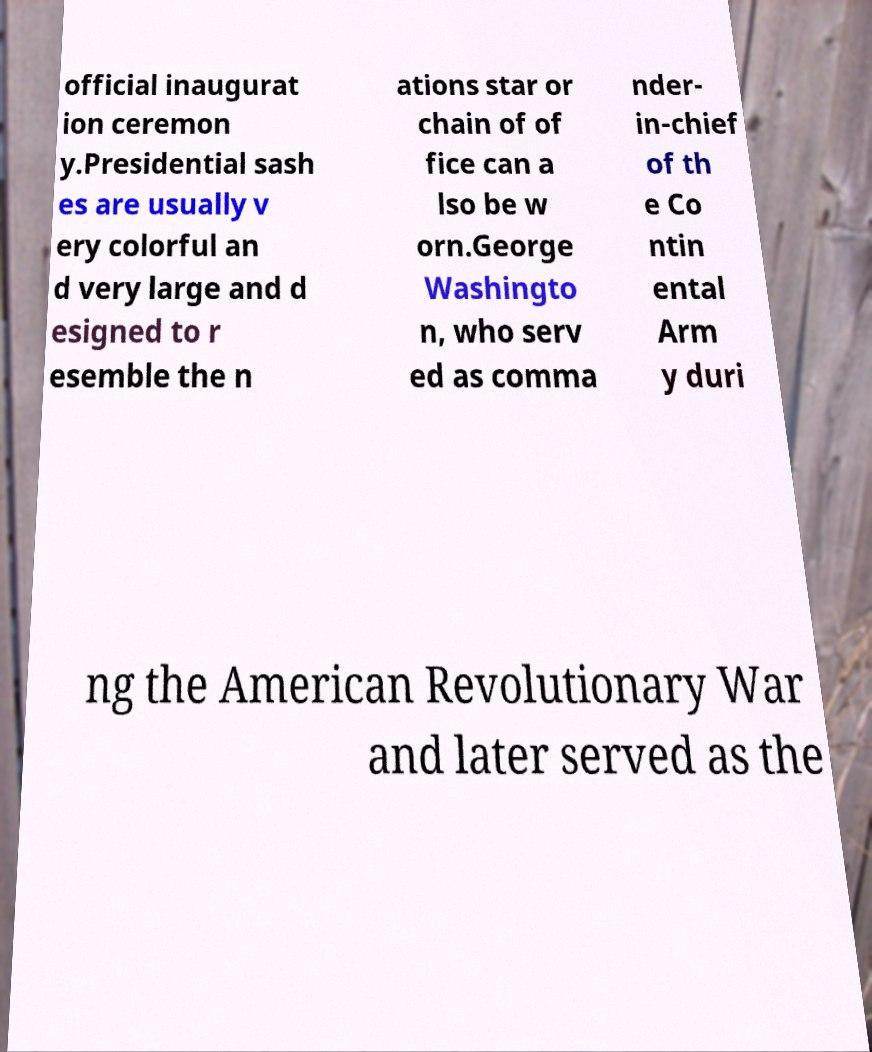There's text embedded in this image that I need extracted. Can you transcribe it verbatim? official inaugurat ion ceremon y.Presidential sash es are usually v ery colorful an d very large and d esigned to r esemble the n ations star or chain of of fice can a lso be w orn.George Washingto n, who serv ed as comma nder- in-chief of th e Co ntin ental Arm y duri ng the American Revolutionary War and later served as the 